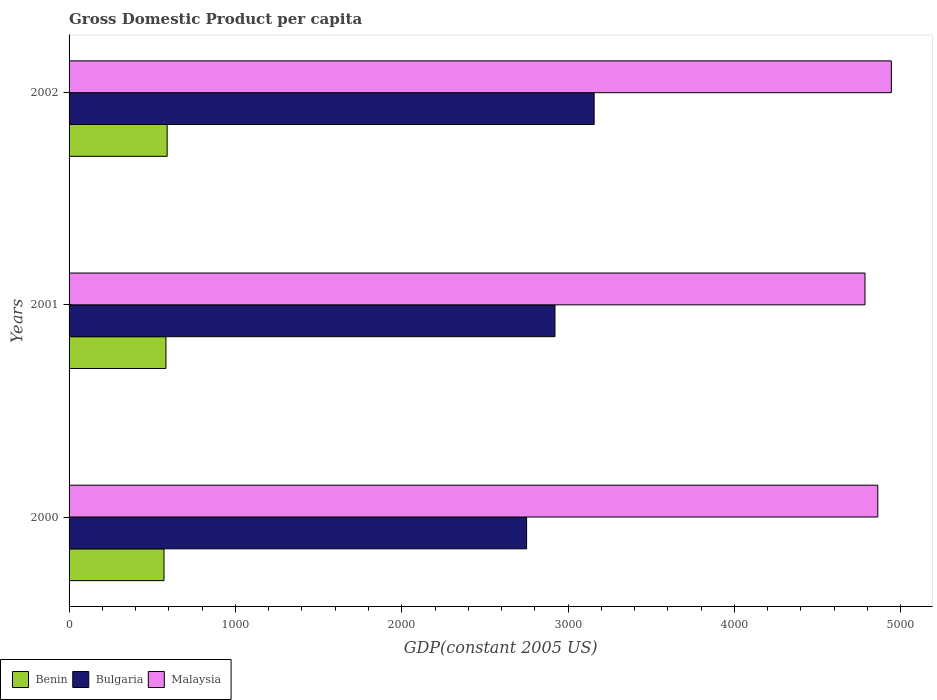How many groups of bars are there?
Your answer should be compact. 3. Are the number of bars per tick equal to the number of legend labels?
Make the answer very short. Yes. Are the number of bars on each tick of the Y-axis equal?
Offer a very short reply. Yes. What is the label of the 3rd group of bars from the top?
Your response must be concise. 2000. In how many cases, is the number of bars for a given year not equal to the number of legend labels?
Your answer should be very brief. 0. What is the GDP per capita in Malaysia in 2000?
Keep it short and to the point. 4861.89. Across all years, what is the maximum GDP per capita in Benin?
Your answer should be compact. 589.63. Across all years, what is the minimum GDP per capita in Benin?
Make the answer very short. 570.77. What is the total GDP per capita in Malaysia in the graph?
Offer a terse response. 1.46e+04. What is the difference between the GDP per capita in Benin in 2000 and that in 2002?
Your answer should be very brief. -18.86. What is the difference between the GDP per capita in Bulgaria in 2000 and the GDP per capita in Malaysia in 2002?
Offer a very short reply. -2192.83. What is the average GDP per capita in Bulgaria per year?
Ensure brevity in your answer.  2942.72. In the year 2000, what is the difference between the GDP per capita in Bulgaria and GDP per capita in Benin?
Your answer should be compact. 2179.82. What is the ratio of the GDP per capita in Benin in 2000 to that in 2001?
Your answer should be compact. 0.98. What is the difference between the highest and the second highest GDP per capita in Benin?
Your answer should be very brief. 7.34. What is the difference between the highest and the lowest GDP per capita in Malaysia?
Keep it short and to the point. 158.55. What does the 2nd bar from the top in 2001 represents?
Offer a terse response. Bulgaria. What does the 3rd bar from the bottom in 2000 represents?
Your answer should be compact. Malaysia. Is it the case that in every year, the sum of the GDP per capita in Benin and GDP per capita in Bulgaria is greater than the GDP per capita in Malaysia?
Provide a succinct answer. No. How many bars are there?
Make the answer very short. 9. How many years are there in the graph?
Offer a terse response. 3. What is the difference between two consecutive major ticks on the X-axis?
Provide a succinct answer. 1000. Are the values on the major ticks of X-axis written in scientific E-notation?
Offer a very short reply. No. Does the graph contain any zero values?
Your answer should be compact. No. Does the graph contain grids?
Offer a very short reply. No. How many legend labels are there?
Ensure brevity in your answer.  3. What is the title of the graph?
Your answer should be very brief. Gross Domestic Product per capita. What is the label or title of the X-axis?
Keep it short and to the point. GDP(constant 2005 US). What is the GDP(constant 2005 US) in Benin in 2000?
Offer a very short reply. 570.77. What is the GDP(constant 2005 US) of Bulgaria in 2000?
Offer a terse response. 2750.59. What is the GDP(constant 2005 US) in Malaysia in 2000?
Provide a succinct answer. 4861.89. What is the GDP(constant 2005 US) in Benin in 2001?
Your answer should be compact. 582.3. What is the GDP(constant 2005 US) in Bulgaria in 2001?
Offer a very short reply. 2921.02. What is the GDP(constant 2005 US) in Malaysia in 2001?
Offer a very short reply. 4784.87. What is the GDP(constant 2005 US) in Benin in 2002?
Offer a terse response. 589.63. What is the GDP(constant 2005 US) in Bulgaria in 2002?
Offer a terse response. 3156.56. What is the GDP(constant 2005 US) in Malaysia in 2002?
Your answer should be compact. 4943.41. Across all years, what is the maximum GDP(constant 2005 US) in Benin?
Provide a succinct answer. 589.63. Across all years, what is the maximum GDP(constant 2005 US) in Bulgaria?
Your answer should be compact. 3156.56. Across all years, what is the maximum GDP(constant 2005 US) of Malaysia?
Ensure brevity in your answer.  4943.41. Across all years, what is the minimum GDP(constant 2005 US) in Benin?
Provide a short and direct response. 570.77. Across all years, what is the minimum GDP(constant 2005 US) of Bulgaria?
Offer a very short reply. 2750.59. Across all years, what is the minimum GDP(constant 2005 US) in Malaysia?
Make the answer very short. 4784.87. What is the total GDP(constant 2005 US) of Benin in the graph?
Make the answer very short. 1742.7. What is the total GDP(constant 2005 US) in Bulgaria in the graph?
Make the answer very short. 8828.17. What is the total GDP(constant 2005 US) of Malaysia in the graph?
Offer a terse response. 1.46e+04. What is the difference between the GDP(constant 2005 US) of Benin in 2000 and that in 2001?
Provide a succinct answer. -11.53. What is the difference between the GDP(constant 2005 US) in Bulgaria in 2000 and that in 2001?
Offer a very short reply. -170.43. What is the difference between the GDP(constant 2005 US) of Malaysia in 2000 and that in 2001?
Ensure brevity in your answer.  77.02. What is the difference between the GDP(constant 2005 US) in Benin in 2000 and that in 2002?
Provide a succinct answer. -18.86. What is the difference between the GDP(constant 2005 US) of Bulgaria in 2000 and that in 2002?
Offer a terse response. -405.98. What is the difference between the GDP(constant 2005 US) in Malaysia in 2000 and that in 2002?
Offer a very short reply. -81.52. What is the difference between the GDP(constant 2005 US) of Benin in 2001 and that in 2002?
Ensure brevity in your answer.  -7.34. What is the difference between the GDP(constant 2005 US) in Bulgaria in 2001 and that in 2002?
Your answer should be very brief. -235.54. What is the difference between the GDP(constant 2005 US) in Malaysia in 2001 and that in 2002?
Your response must be concise. -158.55. What is the difference between the GDP(constant 2005 US) of Benin in 2000 and the GDP(constant 2005 US) of Bulgaria in 2001?
Ensure brevity in your answer.  -2350.25. What is the difference between the GDP(constant 2005 US) of Benin in 2000 and the GDP(constant 2005 US) of Malaysia in 2001?
Your answer should be very brief. -4214.1. What is the difference between the GDP(constant 2005 US) of Bulgaria in 2000 and the GDP(constant 2005 US) of Malaysia in 2001?
Provide a short and direct response. -2034.28. What is the difference between the GDP(constant 2005 US) of Benin in 2000 and the GDP(constant 2005 US) of Bulgaria in 2002?
Offer a very short reply. -2585.79. What is the difference between the GDP(constant 2005 US) of Benin in 2000 and the GDP(constant 2005 US) of Malaysia in 2002?
Make the answer very short. -4372.64. What is the difference between the GDP(constant 2005 US) of Bulgaria in 2000 and the GDP(constant 2005 US) of Malaysia in 2002?
Provide a short and direct response. -2192.83. What is the difference between the GDP(constant 2005 US) in Benin in 2001 and the GDP(constant 2005 US) in Bulgaria in 2002?
Provide a succinct answer. -2574.27. What is the difference between the GDP(constant 2005 US) in Benin in 2001 and the GDP(constant 2005 US) in Malaysia in 2002?
Offer a very short reply. -4361.12. What is the difference between the GDP(constant 2005 US) in Bulgaria in 2001 and the GDP(constant 2005 US) in Malaysia in 2002?
Provide a succinct answer. -2022.39. What is the average GDP(constant 2005 US) in Benin per year?
Make the answer very short. 580.9. What is the average GDP(constant 2005 US) of Bulgaria per year?
Keep it short and to the point. 2942.72. What is the average GDP(constant 2005 US) of Malaysia per year?
Offer a terse response. 4863.39. In the year 2000, what is the difference between the GDP(constant 2005 US) of Benin and GDP(constant 2005 US) of Bulgaria?
Your response must be concise. -2179.82. In the year 2000, what is the difference between the GDP(constant 2005 US) in Benin and GDP(constant 2005 US) in Malaysia?
Provide a succinct answer. -4291.12. In the year 2000, what is the difference between the GDP(constant 2005 US) of Bulgaria and GDP(constant 2005 US) of Malaysia?
Provide a succinct answer. -2111.3. In the year 2001, what is the difference between the GDP(constant 2005 US) in Benin and GDP(constant 2005 US) in Bulgaria?
Keep it short and to the point. -2338.73. In the year 2001, what is the difference between the GDP(constant 2005 US) of Benin and GDP(constant 2005 US) of Malaysia?
Keep it short and to the point. -4202.57. In the year 2001, what is the difference between the GDP(constant 2005 US) of Bulgaria and GDP(constant 2005 US) of Malaysia?
Make the answer very short. -1863.84. In the year 2002, what is the difference between the GDP(constant 2005 US) in Benin and GDP(constant 2005 US) in Bulgaria?
Your response must be concise. -2566.93. In the year 2002, what is the difference between the GDP(constant 2005 US) in Benin and GDP(constant 2005 US) in Malaysia?
Your response must be concise. -4353.78. In the year 2002, what is the difference between the GDP(constant 2005 US) of Bulgaria and GDP(constant 2005 US) of Malaysia?
Provide a short and direct response. -1786.85. What is the ratio of the GDP(constant 2005 US) in Benin in 2000 to that in 2001?
Make the answer very short. 0.98. What is the ratio of the GDP(constant 2005 US) of Bulgaria in 2000 to that in 2001?
Make the answer very short. 0.94. What is the ratio of the GDP(constant 2005 US) of Malaysia in 2000 to that in 2001?
Keep it short and to the point. 1.02. What is the ratio of the GDP(constant 2005 US) of Benin in 2000 to that in 2002?
Provide a short and direct response. 0.97. What is the ratio of the GDP(constant 2005 US) of Bulgaria in 2000 to that in 2002?
Make the answer very short. 0.87. What is the ratio of the GDP(constant 2005 US) of Malaysia in 2000 to that in 2002?
Your response must be concise. 0.98. What is the ratio of the GDP(constant 2005 US) in Benin in 2001 to that in 2002?
Offer a terse response. 0.99. What is the ratio of the GDP(constant 2005 US) in Bulgaria in 2001 to that in 2002?
Your answer should be compact. 0.93. What is the ratio of the GDP(constant 2005 US) in Malaysia in 2001 to that in 2002?
Keep it short and to the point. 0.97. What is the difference between the highest and the second highest GDP(constant 2005 US) of Benin?
Keep it short and to the point. 7.34. What is the difference between the highest and the second highest GDP(constant 2005 US) of Bulgaria?
Your answer should be very brief. 235.54. What is the difference between the highest and the second highest GDP(constant 2005 US) of Malaysia?
Your response must be concise. 81.52. What is the difference between the highest and the lowest GDP(constant 2005 US) in Benin?
Keep it short and to the point. 18.86. What is the difference between the highest and the lowest GDP(constant 2005 US) of Bulgaria?
Give a very brief answer. 405.98. What is the difference between the highest and the lowest GDP(constant 2005 US) of Malaysia?
Your answer should be compact. 158.55. 